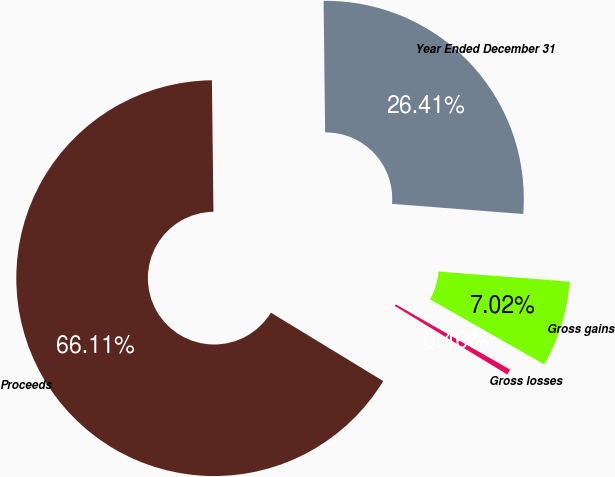<chart> <loc_0><loc_0><loc_500><loc_500><pie_chart><fcel>Year Ended December 31<fcel>Gross gains<fcel>Gross losses<fcel>Proceeds<nl><fcel>26.41%<fcel>7.02%<fcel>0.46%<fcel>66.11%<nl></chart> 